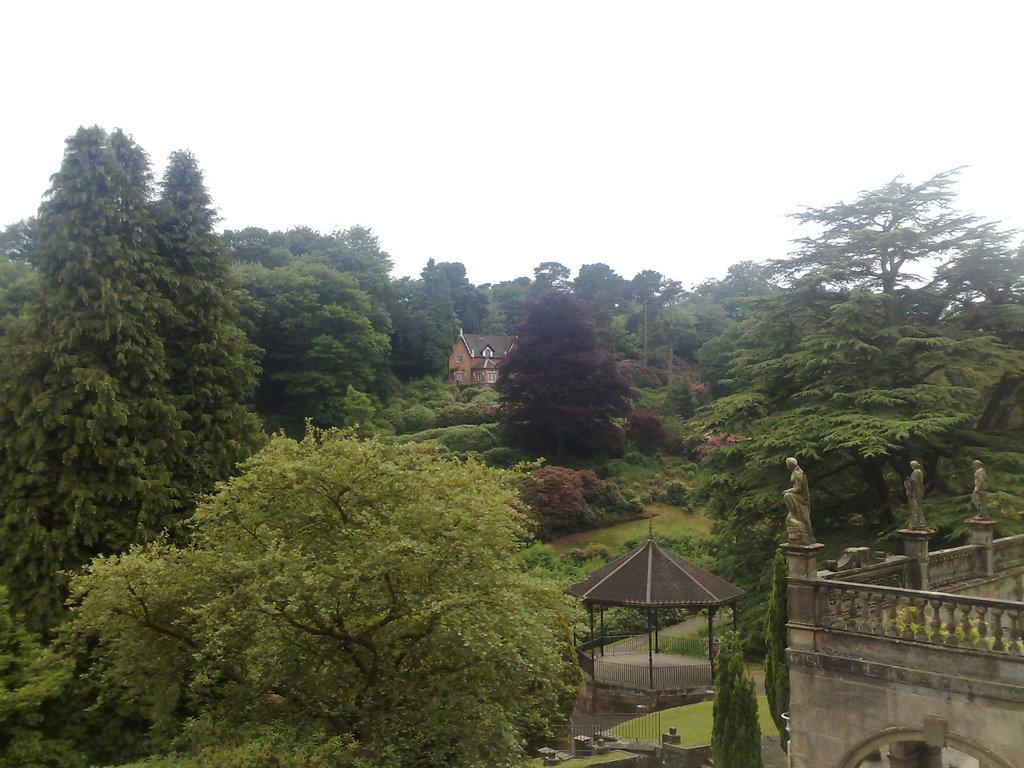What type of vegetation is present in the image? There are many trees and grass in the image. What type of structure can be seen in the image? There is a house and a building in the image. Are there any artistic elements in the image? Yes, there are sculptures in the image. What can be seen in the background of the image? Sky is visible in the image. What type of fruit is hanging from the trees in the image? There is no fruit hanging from the trees in the image; only trees and grass are present. What can be seen being drawn with chalk in the image? There is no chalk or drawing activity present in the image. 